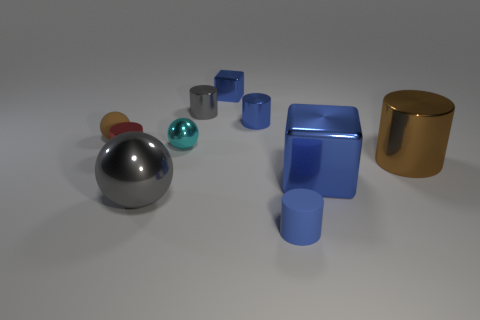Subtract all matte cylinders. How many cylinders are left? 4 Subtract 2 cylinders. How many cylinders are left? 3 Subtract all cyan cylinders. Subtract all red blocks. How many cylinders are left? 5 Subtract all spheres. How many objects are left? 7 Add 7 large things. How many large things are left? 10 Add 8 large cylinders. How many large cylinders exist? 9 Subtract 2 blue blocks. How many objects are left? 8 Subtract all brown cylinders. Subtract all large brown metal cylinders. How many objects are left? 8 